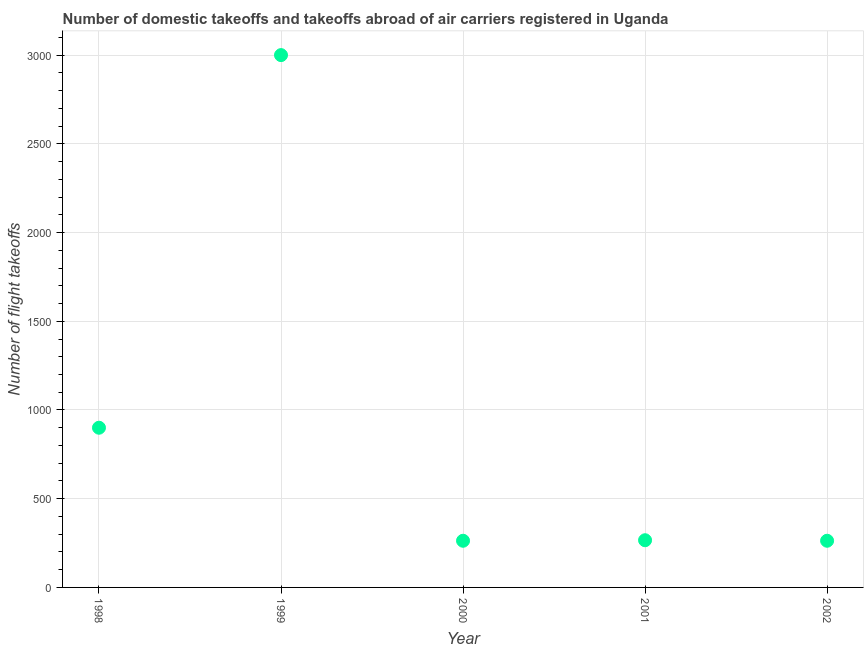What is the number of flight takeoffs in 2001?
Offer a terse response. 266. Across all years, what is the maximum number of flight takeoffs?
Make the answer very short. 3000. Across all years, what is the minimum number of flight takeoffs?
Offer a very short reply. 263. In which year was the number of flight takeoffs maximum?
Give a very brief answer. 1999. What is the sum of the number of flight takeoffs?
Ensure brevity in your answer.  4692. What is the difference between the number of flight takeoffs in 1999 and 2000?
Your answer should be compact. 2737. What is the average number of flight takeoffs per year?
Your response must be concise. 938.4. What is the median number of flight takeoffs?
Make the answer very short. 266. Do a majority of the years between 2000 and 1998 (inclusive) have number of flight takeoffs greater than 1200 ?
Your response must be concise. No. What is the ratio of the number of flight takeoffs in 2001 to that in 2002?
Offer a terse response. 1.01. Is the number of flight takeoffs in 1999 less than that in 2002?
Give a very brief answer. No. What is the difference between the highest and the second highest number of flight takeoffs?
Your answer should be compact. 2100. What is the difference between the highest and the lowest number of flight takeoffs?
Make the answer very short. 2737. Does the number of flight takeoffs monotonically increase over the years?
Give a very brief answer. No. How many years are there in the graph?
Offer a very short reply. 5. Are the values on the major ticks of Y-axis written in scientific E-notation?
Your answer should be compact. No. Does the graph contain any zero values?
Offer a terse response. No. What is the title of the graph?
Offer a very short reply. Number of domestic takeoffs and takeoffs abroad of air carriers registered in Uganda. What is the label or title of the X-axis?
Your response must be concise. Year. What is the label or title of the Y-axis?
Offer a very short reply. Number of flight takeoffs. What is the Number of flight takeoffs in 1998?
Offer a very short reply. 900. What is the Number of flight takeoffs in 1999?
Make the answer very short. 3000. What is the Number of flight takeoffs in 2000?
Make the answer very short. 263. What is the Number of flight takeoffs in 2001?
Offer a terse response. 266. What is the Number of flight takeoffs in 2002?
Provide a succinct answer. 263. What is the difference between the Number of flight takeoffs in 1998 and 1999?
Ensure brevity in your answer.  -2100. What is the difference between the Number of flight takeoffs in 1998 and 2000?
Your response must be concise. 637. What is the difference between the Number of flight takeoffs in 1998 and 2001?
Make the answer very short. 634. What is the difference between the Number of flight takeoffs in 1998 and 2002?
Ensure brevity in your answer.  637. What is the difference between the Number of flight takeoffs in 1999 and 2000?
Your answer should be very brief. 2737. What is the difference between the Number of flight takeoffs in 1999 and 2001?
Your response must be concise. 2734. What is the difference between the Number of flight takeoffs in 1999 and 2002?
Give a very brief answer. 2737. What is the difference between the Number of flight takeoffs in 2000 and 2001?
Provide a short and direct response. -3. What is the difference between the Number of flight takeoffs in 2000 and 2002?
Ensure brevity in your answer.  0. What is the difference between the Number of flight takeoffs in 2001 and 2002?
Your response must be concise. 3. What is the ratio of the Number of flight takeoffs in 1998 to that in 2000?
Keep it short and to the point. 3.42. What is the ratio of the Number of flight takeoffs in 1998 to that in 2001?
Your answer should be compact. 3.38. What is the ratio of the Number of flight takeoffs in 1998 to that in 2002?
Your response must be concise. 3.42. What is the ratio of the Number of flight takeoffs in 1999 to that in 2000?
Provide a short and direct response. 11.41. What is the ratio of the Number of flight takeoffs in 1999 to that in 2001?
Your answer should be compact. 11.28. What is the ratio of the Number of flight takeoffs in 1999 to that in 2002?
Your response must be concise. 11.41. What is the ratio of the Number of flight takeoffs in 2000 to that in 2002?
Provide a succinct answer. 1. What is the ratio of the Number of flight takeoffs in 2001 to that in 2002?
Make the answer very short. 1.01. 